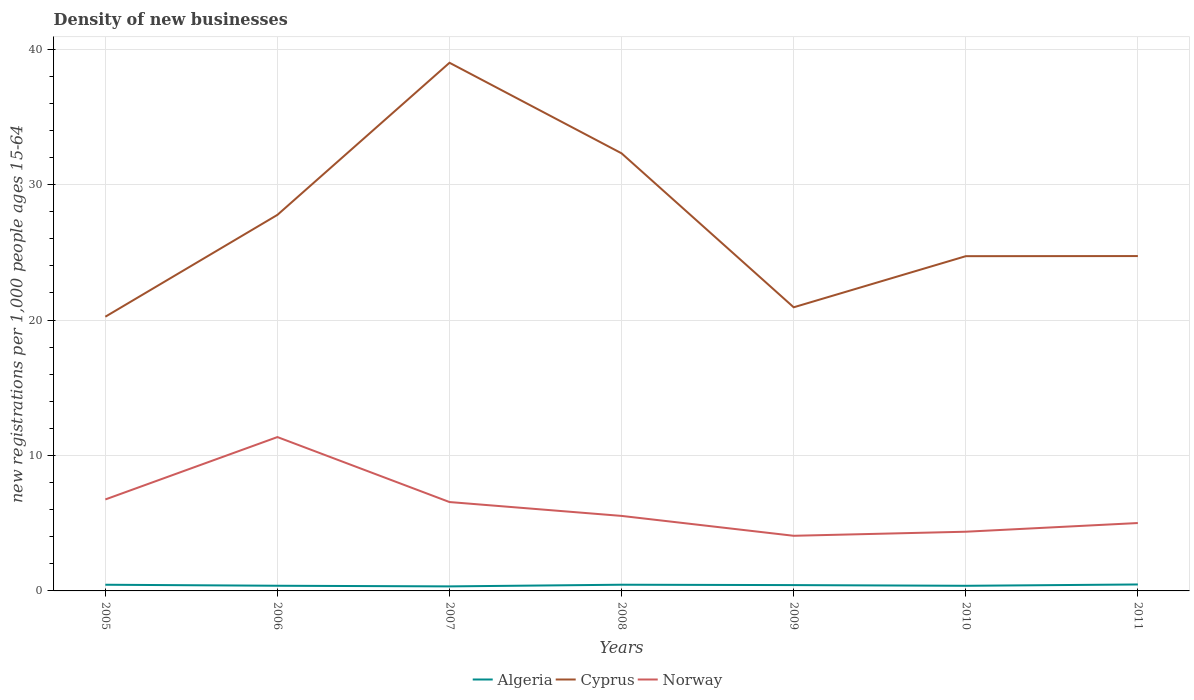How many different coloured lines are there?
Your answer should be compact. 3. Is the number of lines equal to the number of legend labels?
Your answer should be compact. Yes. Across all years, what is the maximum number of new registrations in Algeria?
Provide a succinct answer. 0.33. In which year was the number of new registrations in Norway maximum?
Offer a very short reply. 2009. What is the total number of new registrations in Norway in the graph?
Your response must be concise. 4.8. What is the difference between the highest and the second highest number of new registrations in Algeria?
Offer a very short reply. 0.14. What is the difference between the highest and the lowest number of new registrations in Norway?
Provide a succinct answer. 3. How many years are there in the graph?
Your response must be concise. 7. Does the graph contain any zero values?
Keep it short and to the point. No. Where does the legend appear in the graph?
Ensure brevity in your answer.  Bottom center. How are the legend labels stacked?
Your answer should be compact. Horizontal. What is the title of the graph?
Give a very brief answer. Density of new businesses. What is the label or title of the X-axis?
Your answer should be very brief. Years. What is the label or title of the Y-axis?
Give a very brief answer. New registrations per 1,0 people ages 15-64. What is the new registrations per 1,000 people ages 15-64 in Algeria in 2005?
Ensure brevity in your answer.  0.46. What is the new registrations per 1,000 people ages 15-64 of Cyprus in 2005?
Offer a very short reply. 20.25. What is the new registrations per 1,000 people ages 15-64 in Norway in 2005?
Provide a short and direct response. 6.75. What is the new registrations per 1,000 people ages 15-64 of Algeria in 2006?
Offer a terse response. 0.38. What is the new registrations per 1,000 people ages 15-64 of Cyprus in 2006?
Your answer should be very brief. 27.77. What is the new registrations per 1,000 people ages 15-64 in Norway in 2006?
Give a very brief answer. 11.36. What is the new registrations per 1,000 people ages 15-64 in Algeria in 2007?
Give a very brief answer. 0.33. What is the new registrations per 1,000 people ages 15-64 of Cyprus in 2007?
Offer a very short reply. 39. What is the new registrations per 1,000 people ages 15-64 in Norway in 2007?
Ensure brevity in your answer.  6.56. What is the new registrations per 1,000 people ages 15-64 of Algeria in 2008?
Give a very brief answer. 0.46. What is the new registrations per 1,000 people ages 15-64 of Cyprus in 2008?
Make the answer very short. 32.31. What is the new registrations per 1,000 people ages 15-64 of Norway in 2008?
Provide a succinct answer. 5.54. What is the new registrations per 1,000 people ages 15-64 of Algeria in 2009?
Offer a terse response. 0.43. What is the new registrations per 1,000 people ages 15-64 in Cyprus in 2009?
Your answer should be very brief. 20.94. What is the new registrations per 1,000 people ages 15-64 in Norway in 2009?
Your answer should be very brief. 4.07. What is the new registrations per 1,000 people ages 15-64 in Algeria in 2010?
Ensure brevity in your answer.  0.38. What is the new registrations per 1,000 people ages 15-64 in Cyprus in 2010?
Make the answer very short. 24.72. What is the new registrations per 1,000 people ages 15-64 of Norway in 2010?
Give a very brief answer. 4.37. What is the new registrations per 1,000 people ages 15-64 in Algeria in 2011?
Provide a succinct answer. 0.48. What is the new registrations per 1,000 people ages 15-64 in Cyprus in 2011?
Provide a succinct answer. 24.73. What is the new registrations per 1,000 people ages 15-64 of Norway in 2011?
Make the answer very short. 5.01. Across all years, what is the maximum new registrations per 1,000 people ages 15-64 of Algeria?
Offer a very short reply. 0.48. Across all years, what is the maximum new registrations per 1,000 people ages 15-64 of Cyprus?
Provide a short and direct response. 39. Across all years, what is the maximum new registrations per 1,000 people ages 15-64 of Norway?
Give a very brief answer. 11.36. Across all years, what is the minimum new registrations per 1,000 people ages 15-64 in Algeria?
Give a very brief answer. 0.33. Across all years, what is the minimum new registrations per 1,000 people ages 15-64 of Cyprus?
Your response must be concise. 20.25. Across all years, what is the minimum new registrations per 1,000 people ages 15-64 of Norway?
Your answer should be compact. 4.07. What is the total new registrations per 1,000 people ages 15-64 of Algeria in the graph?
Provide a short and direct response. 2.92. What is the total new registrations per 1,000 people ages 15-64 in Cyprus in the graph?
Offer a very short reply. 189.72. What is the total new registrations per 1,000 people ages 15-64 of Norway in the graph?
Offer a terse response. 43.67. What is the difference between the new registrations per 1,000 people ages 15-64 of Algeria in 2005 and that in 2006?
Your answer should be compact. 0.08. What is the difference between the new registrations per 1,000 people ages 15-64 in Cyprus in 2005 and that in 2006?
Your answer should be compact. -7.52. What is the difference between the new registrations per 1,000 people ages 15-64 in Norway in 2005 and that in 2006?
Make the answer very short. -4.61. What is the difference between the new registrations per 1,000 people ages 15-64 of Algeria in 2005 and that in 2007?
Provide a short and direct response. 0.12. What is the difference between the new registrations per 1,000 people ages 15-64 of Cyprus in 2005 and that in 2007?
Make the answer very short. -18.75. What is the difference between the new registrations per 1,000 people ages 15-64 of Norway in 2005 and that in 2007?
Your answer should be very brief. 0.19. What is the difference between the new registrations per 1,000 people ages 15-64 of Algeria in 2005 and that in 2008?
Ensure brevity in your answer.  -0. What is the difference between the new registrations per 1,000 people ages 15-64 of Cyprus in 2005 and that in 2008?
Make the answer very short. -12.06. What is the difference between the new registrations per 1,000 people ages 15-64 of Norway in 2005 and that in 2008?
Give a very brief answer. 1.22. What is the difference between the new registrations per 1,000 people ages 15-64 in Algeria in 2005 and that in 2009?
Offer a very short reply. 0.03. What is the difference between the new registrations per 1,000 people ages 15-64 of Cyprus in 2005 and that in 2009?
Give a very brief answer. -0.7. What is the difference between the new registrations per 1,000 people ages 15-64 of Norway in 2005 and that in 2009?
Make the answer very short. 2.68. What is the difference between the new registrations per 1,000 people ages 15-64 in Algeria in 2005 and that in 2010?
Provide a succinct answer. 0.08. What is the difference between the new registrations per 1,000 people ages 15-64 in Cyprus in 2005 and that in 2010?
Provide a short and direct response. -4.47. What is the difference between the new registrations per 1,000 people ages 15-64 in Norway in 2005 and that in 2010?
Provide a succinct answer. 2.38. What is the difference between the new registrations per 1,000 people ages 15-64 in Algeria in 2005 and that in 2011?
Your response must be concise. -0.02. What is the difference between the new registrations per 1,000 people ages 15-64 of Cyprus in 2005 and that in 2011?
Ensure brevity in your answer.  -4.48. What is the difference between the new registrations per 1,000 people ages 15-64 in Norway in 2005 and that in 2011?
Provide a succinct answer. 1.74. What is the difference between the new registrations per 1,000 people ages 15-64 in Algeria in 2006 and that in 2007?
Offer a very short reply. 0.05. What is the difference between the new registrations per 1,000 people ages 15-64 in Cyprus in 2006 and that in 2007?
Your response must be concise. -11.23. What is the difference between the new registrations per 1,000 people ages 15-64 in Norway in 2006 and that in 2007?
Provide a short and direct response. 4.8. What is the difference between the new registrations per 1,000 people ages 15-64 of Algeria in 2006 and that in 2008?
Give a very brief answer. -0.08. What is the difference between the new registrations per 1,000 people ages 15-64 of Cyprus in 2006 and that in 2008?
Your answer should be very brief. -4.54. What is the difference between the new registrations per 1,000 people ages 15-64 in Norway in 2006 and that in 2008?
Offer a terse response. 5.82. What is the difference between the new registrations per 1,000 people ages 15-64 of Algeria in 2006 and that in 2009?
Offer a very short reply. -0.05. What is the difference between the new registrations per 1,000 people ages 15-64 of Cyprus in 2006 and that in 2009?
Ensure brevity in your answer.  6.83. What is the difference between the new registrations per 1,000 people ages 15-64 in Norway in 2006 and that in 2009?
Give a very brief answer. 7.29. What is the difference between the new registrations per 1,000 people ages 15-64 of Algeria in 2006 and that in 2010?
Your answer should be very brief. 0. What is the difference between the new registrations per 1,000 people ages 15-64 in Cyprus in 2006 and that in 2010?
Ensure brevity in your answer.  3.05. What is the difference between the new registrations per 1,000 people ages 15-64 of Norway in 2006 and that in 2010?
Provide a short and direct response. 6.99. What is the difference between the new registrations per 1,000 people ages 15-64 in Algeria in 2006 and that in 2011?
Provide a short and direct response. -0.1. What is the difference between the new registrations per 1,000 people ages 15-64 of Cyprus in 2006 and that in 2011?
Keep it short and to the point. 3.04. What is the difference between the new registrations per 1,000 people ages 15-64 of Norway in 2006 and that in 2011?
Keep it short and to the point. 6.35. What is the difference between the new registrations per 1,000 people ages 15-64 in Algeria in 2007 and that in 2008?
Offer a very short reply. -0.12. What is the difference between the new registrations per 1,000 people ages 15-64 in Cyprus in 2007 and that in 2008?
Your response must be concise. 6.69. What is the difference between the new registrations per 1,000 people ages 15-64 in Norway in 2007 and that in 2008?
Provide a short and direct response. 1.02. What is the difference between the new registrations per 1,000 people ages 15-64 of Algeria in 2007 and that in 2009?
Provide a succinct answer. -0.1. What is the difference between the new registrations per 1,000 people ages 15-64 of Cyprus in 2007 and that in 2009?
Make the answer very short. 18.06. What is the difference between the new registrations per 1,000 people ages 15-64 of Norway in 2007 and that in 2009?
Your answer should be very brief. 2.49. What is the difference between the new registrations per 1,000 people ages 15-64 of Algeria in 2007 and that in 2010?
Your answer should be compact. -0.04. What is the difference between the new registrations per 1,000 people ages 15-64 of Cyprus in 2007 and that in 2010?
Keep it short and to the point. 14.28. What is the difference between the new registrations per 1,000 people ages 15-64 of Norway in 2007 and that in 2010?
Your response must be concise. 2.19. What is the difference between the new registrations per 1,000 people ages 15-64 of Algeria in 2007 and that in 2011?
Give a very brief answer. -0.14. What is the difference between the new registrations per 1,000 people ages 15-64 in Cyprus in 2007 and that in 2011?
Provide a short and direct response. 14.27. What is the difference between the new registrations per 1,000 people ages 15-64 of Norway in 2007 and that in 2011?
Keep it short and to the point. 1.55. What is the difference between the new registrations per 1,000 people ages 15-64 in Algeria in 2008 and that in 2009?
Your answer should be compact. 0.03. What is the difference between the new registrations per 1,000 people ages 15-64 in Cyprus in 2008 and that in 2009?
Ensure brevity in your answer.  11.37. What is the difference between the new registrations per 1,000 people ages 15-64 in Norway in 2008 and that in 2009?
Offer a very short reply. 1.47. What is the difference between the new registrations per 1,000 people ages 15-64 in Algeria in 2008 and that in 2010?
Make the answer very short. 0.08. What is the difference between the new registrations per 1,000 people ages 15-64 in Cyprus in 2008 and that in 2010?
Provide a succinct answer. 7.59. What is the difference between the new registrations per 1,000 people ages 15-64 in Norway in 2008 and that in 2010?
Offer a very short reply. 1.17. What is the difference between the new registrations per 1,000 people ages 15-64 in Algeria in 2008 and that in 2011?
Keep it short and to the point. -0.02. What is the difference between the new registrations per 1,000 people ages 15-64 of Cyprus in 2008 and that in 2011?
Give a very brief answer. 7.58. What is the difference between the new registrations per 1,000 people ages 15-64 in Norway in 2008 and that in 2011?
Your answer should be compact. 0.53. What is the difference between the new registrations per 1,000 people ages 15-64 in Algeria in 2009 and that in 2010?
Provide a short and direct response. 0.05. What is the difference between the new registrations per 1,000 people ages 15-64 of Cyprus in 2009 and that in 2010?
Your answer should be compact. -3.77. What is the difference between the new registrations per 1,000 people ages 15-64 of Norway in 2009 and that in 2010?
Ensure brevity in your answer.  -0.3. What is the difference between the new registrations per 1,000 people ages 15-64 of Algeria in 2009 and that in 2011?
Make the answer very short. -0.05. What is the difference between the new registrations per 1,000 people ages 15-64 in Cyprus in 2009 and that in 2011?
Provide a short and direct response. -3.78. What is the difference between the new registrations per 1,000 people ages 15-64 of Norway in 2009 and that in 2011?
Provide a succinct answer. -0.94. What is the difference between the new registrations per 1,000 people ages 15-64 of Algeria in 2010 and that in 2011?
Give a very brief answer. -0.1. What is the difference between the new registrations per 1,000 people ages 15-64 of Cyprus in 2010 and that in 2011?
Keep it short and to the point. -0.01. What is the difference between the new registrations per 1,000 people ages 15-64 of Norway in 2010 and that in 2011?
Your answer should be very brief. -0.64. What is the difference between the new registrations per 1,000 people ages 15-64 of Algeria in 2005 and the new registrations per 1,000 people ages 15-64 of Cyprus in 2006?
Ensure brevity in your answer.  -27.31. What is the difference between the new registrations per 1,000 people ages 15-64 in Algeria in 2005 and the new registrations per 1,000 people ages 15-64 in Norway in 2006?
Your answer should be compact. -10.9. What is the difference between the new registrations per 1,000 people ages 15-64 of Cyprus in 2005 and the new registrations per 1,000 people ages 15-64 of Norway in 2006?
Your answer should be compact. 8.89. What is the difference between the new registrations per 1,000 people ages 15-64 in Algeria in 2005 and the new registrations per 1,000 people ages 15-64 in Cyprus in 2007?
Your answer should be compact. -38.54. What is the difference between the new registrations per 1,000 people ages 15-64 in Algeria in 2005 and the new registrations per 1,000 people ages 15-64 in Norway in 2007?
Ensure brevity in your answer.  -6.11. What is the difference between the new registrations per 1,000 people ages 15-64 of Cyprus in 2005 and the new registrations per 1,000 people ages 15-64 of Norway in 2007?
Ensure brevity in your answer.  13.69. What is the difference between the new registrations per 1,000 people ages 15-64 of Algeria in 2005 and the new registrations per 1,000 people ages 15-64 of Cyprus in 2008?
Your answer should be compact. -31.85. What is the difference between the new registrations per 1,000 people ages 15-64 of Algeria in 2005 and the new registrations per 1,000 people ages 15-64 of Norway in 2008?
Your answer should be very brief. -5.08. What is the difference between the new registrations per 1,000 people ages 15-64 in Cyprus in 2005 and the new registrations per 1,000 people ages 15-64 in Norway in 2008?
Give a very brief answer. 14.71. What is the difference between the new registrations per 1,000 people ages 15-64 in Algeria in 2005 and the new registrations per 1,000 people ages 15-64 in Cyprus in 2009?
Offer a terse response. -20.49. What is the difference between the new registrations per 1,000 people ages 15-64 in Algeria in 2005 and the new registrations per 1,000 people ages 15-64 in Norway in 2009?
Your answer should be very brief. -3.61. What is the difference between the new registrations per 1,000 people ages 15-64 in Cyprus in 2005 and the new registrations per 1,000 people ages 15-64 in Norway in 2009?
Give a very brief answer. 16.18. What is the difference between the new registrations per 1,000 people ages 15-64 of Algeria in 2005 and the new registrations per 1,000 people ages 15-64 of Cyprus in 2010?
Ensure brevity in your answer.  -24.26. What is the difference between the new registrations per 1,000 people ages 15-64 of Algeria in 2005 and the new registrations per 1,000 people ages 15-64 of Norway in 2010?
Your response must be concise. -3.91. What is the difference between the new registrations per 1,000 people ages 15-64 in Cyprus in 2005 and the new registrations per 1,000 people ages 15-64 in Norway in 2010?
Your answer should be very brief. 15.88. What is the difference between the new registrations per 1,000 people ages 15-64 of Algeria in 2005 and the new registrations per 1,000 people ages 15-64 of Cyprus in 2011?
Provide a succinct answer. -24.27. What is the difference between the new registrations per 1,000 people ages 15-64 of Algeria in 2005 and the new registrations per 1,000 people ages 15-64 of Norway in 2011?
Make the answer very short. -4.56. What is the difference between the new registrations per 1,000 people ages 15-64 in Cyprus in 2005 and the new registrations per 1,000 people ages 15-64 in Norway in 2011?
Make the answer very short. 15.23. What is the difference between the new registrations per 1,000 people ages 15-64 in Algeria in 2006 and the new registrations per 1,000 people ages 15-64 in Cyprus in 2007?
Keep it short and to the point. -38.62. What is the difference between the new registrations per 1,000 people ages 15-64 of Algeria in 2006 and the new registrations per 1,000 people ages 15-64 of Norway in 2007?
Your response must be concise. -6.18. What is the difference between the new registrations per 1,000 people ages 15-64 in Cyprus in 2006 and the new registrations per 1,000 people ages 15-64 in Norway in 2007?
Make the answer very short. 21.21. What is the difference between the new registrations per 1,000 people ages 15-64 in Algeria in 2006 and the new registrations per 1,000 people ages 15-64 in Cyprus in 2008?
Ensure brevity in your answer.  -31.93. What is the difference between the new registrations per 1,000 people ages 15-64 in Algeria in 2006 and the new registrations per 1,000 people ages 15-64 in Norway in 2008?
Give a very brief answer. -5.16. What is the difference between the new registrations per 1,000 people ages 15-64 in Cyprus in 2006 and the new registrations per 1,000 people ages 15-64 in Norway in 2008?
Provide a short and direct response. 22.23. What is the difference between the new registrations per 1,000 people ages 15-64 in Algeria in 2006 and the new registrations per 1,000 people ages 15-64 in Cyprus in 2009?
Your response must be concise. -20.56. What is the difference between the new registrations per 1,000 people ages 15-64 in Algeria in 2006 and the new registrations per 1,000 people ages 15-64 in Norway in 2009?
Offer a terse response. -3.69. What is the difference between the new registrations per 1,000 people ages 15-64 in Cyprus in 2006 and the new registrations per 1,000 people ages 15-64 in Norway in 2009?
Provide a short and direct response. 23.7. What is the difference between the new registrations per 1,000 people ages 15-64 of Algeria in 2006 and the new registrations per 1,000 people ages 15-64 of Cyprus in 2010?
Keep it short and to the point. -24.34. What is the difference between the new registrations per 1,000 people ages 15-64 of Algeria in 2006 and the new registrations per 1,000 people ages 15-64 of Norway in 2010?
Your response must be concise. -3.99. What is the difference between the new registrations per 1,000 people ages 15-64 in Cyprus in 2006 and the new registrations per 1,000 people ages 15-64 in Norway in 2010?
Your response must be concise. 23.4. What is the difference between the new registrations per 1,000 people ages 15-64 of Algeria in 2006 and the new registrations per 1,000 people ages 15-64 of Cyprus in 2011?
Your answer should be compact. -24.34. What is the difference between the new registrations per 1,000 people ages 15-64 of Algeria in 2006 and the new registrations per 1,000 people ages 15-64 of Norway in 2011?
Your answer should be very brief. -4.63. What is the difference between the new registrations per 1,000 people ages 15-64 of Cyprus in 2006 and the new registrations per 1,000 people ages 15-64 of Norway in 2011?
Provide a succinct answer. 22.76. What is the difference between the new registrations per 1,000 people ages 15-64 in Algeria in 2007 and the new registrations per 1,000 people ages 15-64 in Cyprus in 2008?
Keep it short and to the point. -31.98. What is the difference between the new registrations per 1,000 people ages 15-64 of Algeria in 2007 and the new registrations per 1,000 people ages 15-64 of Norway in 2008?
Ensure brevity in your answer.  -5.2. What is the difference between the new registrations per 1,000 people ages 15-64 in Cyprus in 2007 and the new registrations per 1,000 people ages 15-64 in Norway in 2008?
Keep it short and to the point. 33.46. What is the difference between the new registrations per 1,000 people ages 15-64 in Algeria in 2007 and the new registrations per 1,000 people ages 15-64 in Cyprus in 2009?
Provide a succinct answer. -20.61. What is the difference between the new registrations per 1,000 people ages 15-64 in Algeria in 2007 and the new registrations per 1,000 people ages 15-64 in Norway in 2009?
Keep it short and to the point. -3.74. What is the difference between the new registrations per 1,000 people ages 15-64 of Cyprus in 2007 and the new registrations per 1,000 people ages 15-64 of Norway in 2009?
Offer a terse response. 34.93. What is the difference between the new registrations per 1,000 people ages 15-64 of Algeria in 2007 and the new registrations per 1,000 people ages 15-64 of Cyprus in 2010?
Your response must be concise. -24.38. What is the difference between the new registrations per 1,000 people ages 15-64 of Algeria in 2007 and the new registrations per 1,000 people ages 15-64 of Norway in 2010?
Ensure brevity in your answer.  -4.04. What is the difference between the new registrations per 1,000 people ages 15-64 in Cyprus in 2007 and the new registrations per 1,000 people ages 15-64 in Norway in 2010?
Keep it short and to the point. 34.63. What is the difference between the new registrations per 1,000 people ages 15-64 in Algeria in 2007 and the new registrations per 1,000 people ages 15-64 in Cyprus in 2011?
Make the answer very short. -24.39. What is the difference between the new registrations per 1,000 people ages 15-64 in Algeria in 2007 and the new registrations per 1,000 people ages 15-64 in Norway in 2011?
Make the answer very short. -4.68. What is the difference between the new registrations per 1,000 people ages 15-64 of Cyprus in 2007 and the new registrations per 1,000 people ages 15-64 of Norway in 2011?
Ensure brevity in your answer.  33.99. What is the difference between the new registrations per 1,000 people ages 15-64 in Algeria in 2008 and the new registrations per 1,000 people ages 15-64 in Cyprus in 2009?
Your response must be concise. -20.49. What is the difference between the new registrations per 1,000 people ages 15-64 in Algeria in 2008 and the new registrations per 1,000 people ages 15-64 in Norway in 2009?
Provide a short and direct response. -3.61. What is the difference between the new registrations per 1,000 people ages 15-64 of Cyprus in 2008 and the new registrations per 1,000 people ages 15-64 of Norway in 2009?
Provide a short and direct response. 28.24. What is the difference between the new registrations per 1,000 people ages 15-64 of Algeria in 2008 and the new registrations per 1,000 people ages 15-64 of Cyprus in 2010?
Ensure brevity in your answer.  -24.26. What is the difference between the new registrations per 1,000 people ages 15-64 of Algeria in 2008 and the new registrations per 1,000 people ages 15-64 of Norway in 2010?
Offer a terse response. -3.91. What is the difference between the new registrations per 1,000 people ages 15-64 in Cyprus in 2008 and the new registrations per 1,000 people ages 15-64 in Norway in 2010?
Your response must be concise. 27.94. What is the difference between the new registrations per 1,000 people ages 15-64 in Algeria in 2008 and the new registrations per 1,000 people ages 15-64 in Cyprus in 2011?
Your response must be concise. -24.27. What is the difference between the new registrations per 1,000 people ages 15-64 of Algeria in 2008 and the new registrations per 1,000 people ages 15-64 of Norway in 2011?
Ensure brevity in your answer.  -4.56. What is the difference between the new registrations per 1,000 people ages 15-64 in Cyprus in 2008 and the new registrations per 1,000 people ages 15-64 in Norway in 2011?
Your answer should be compact. 27.3. What is the difference between the new registrations per 1,000 people ages 15-64 of Algeria in 2009 and the new registrations per 1,000 people ages 15-64 of Cyprus in 2010?
Ensure brevity in your answer.  -24.29. What is the difference between the new registrations per 1,000 people ages 15-64 of Algeria in 2009 and the new registrations per 1,000 people ages 15-64 of Norway in 2010?
Ensure brevity in your answer.  -3.94. What is the difference between the new registrations per 1,000 people ages 15-64 in Cyprus in 2009 and the new registrations per 1,000 people ages 15-64 in Norway in 2010?
Ensure brevity in your answer.  16.57. What is the difference between the new registrations per 1,000 people ages 15-64 in Algeria in 2009 and the new registrations per 1,000 people ages 15-64 in Cyprus in 2011?
Give a very brief answer. -24.3. What is the difference between the new registrations per 1,000 people ages 15-64 of Algeria in 2009 and the new registrations per 1,000 people ages 15-64 of Norway in 2011?
Give a very brief answer. -4.58. What is the difference between the new registrations per 1,000 people ages 15-64 of Cyprus in 2009 and the new registrations per 1,000 people ages 15-64 of Norway in 2011?
Ensure brevity in your answer.  15.93. What is the difference between the new registrations per 1,000 people ages 15-64 of Algeria in 2010 and the new registrations per 1,000 people ages 15-64 of Cyprus in 2011?
Your answer should be compact. -24.35. What is the difference between the new registrations per 1,000 people ages 15-64 of Algeria in 2010 and the new registrations per 1,000 people ages 15-64 of Norway in 2011?
Provide a short and direct response. -4.63. What is the difference between the new registrations per 1,000 people ages 15-64 in Cyprus in 2010 and the new registrations per 1,000 people ages 15-64 in Norway in 2011?
Your response must be concise. 19.71. What is the average new registrations per 1,000 people ages 15-64 in Algeria per year?
Your answer should be very brief. 0.42. What is the average new registrations per 1,000 people ages 15-64 of Cyprus per year?
Offer a very short reply. 27.1. What is the average new registrations per 1,000 people ages 15-64 in Norway per year?
Your answer should be very brief. 6.24. In the year 2005, what is the difference between the new registrations per 1,000 people ages 15-64 in Algeria and new registrations per 1,000 people ages 15-64 in Cyprus?
Your response must be concise. -19.79. In the year 2005, what is the difference between the new registrations per 1,000 people ages 15-64 in Algeria and new registrations per 1,000 people ages 15-64 in Norway?
Your answer should be very brief. -6.3. In the year 2005, what is the difference between the new registrations per 1,000 people ages 15-64 in Cyprus and new registrations per 1,000 people ages 15-64 in Norway?
Your answer should be very brief. 13.49. In the year 2006, what is the difference between the new registrations per 1,000 people ages 15-64 of Algeria and new registrations per 1,000 people ages 15-64 of Cyprus?
Your response must be concise. -27.39. In the year 2006, what is the difference between the new registrations per 1,000 people ages 15-64 in Algeria and new registrations per 1,000 people ages 15-64 in Norway?
Offer a very short reply. -10.98. In the year 2006, what is the difference between the new registrations per 1,000 people ages 15-64 of Cyprus and new registrations per 1,000 people ages 15-64 of Norway?
Your answer should be very brief. 16.41. In the year 2007, what is the difference between the new registrations per 1,000 people ages 15-64 in Algeria and new registrations per 1,000 people ages 15-64 in Cyprus?
Your answer should be compact. -38.67. In the year 2007, what is the difference between the new registrations per 1,000 people ages 15-64 in Algeria and new registrations per 1,000 people ages 15-64 in Norway?
Ensure brevity in your answer.  -6.23. In the year 2007, what is the difference between the new registrations per 1,000 people ages 15-64 of Cyprus and new registrations per 1,000 people ages 15-64 of Norway?
Provide a succinct answer. 32.44. In the year 2008, what is the difference between the new registrations per 1,000 people ages 15-64 of Algeria and new registrations per 1,000 people ages 15-64 of Cyprus?
Your answer should be very brief. -31.85. In the year 2008, what is the difference between the new registrations per 1,000 people ages 15-64 in Algeria and new registrations per 1,000 people ages 15-64 in Norway?
Offer a terse response. -5.08. In the year 2008, what is the difference between the new registrations per 1,000 people ages 15-64 of Cyprus and new registrations per 1,000 people ages 15-64 of Norway?
Your answer should be very brief. 26.77. In the year 2009, what is the difference between the new registrations per 1,000 people ages 15-64 in Algeria and new registrations per 1,000 people ages 15-64 in Cyprus?
Provide a succinct answer. -20.51. In the year 2009, what is the difference between the new registrations per 1,000 people ages 15-64 in Algeria and new registrations per 1,000 people ages 15-64 in Norway?
Offer a terse response. -3.64. In the year 2009, what is the difference between the new registrations per 1,000 people ages 15-64 in Cyprus and new registrations per 1,000 people ages 15-64 in Norway?
Ensure brevity in your answer.  16.87. In the year 2010, what is the difference between the new registrations per 1,000 people ages 15-64 in Algeria and new registrations per 1,000 people ages 15-64 in Cyprus?
Provide a succinct answer. -24.34. In the year 2010, what is the difference between the new registrations per 1,000 people ages 15-64 of Algeria and new registrations per 1,000 people ages 15-64 of Norway?
Offer a terse response. -3.99. In the year 2010, what is the difference between the new registrations per 1,000 people ages 15-64 of Cyprus and new registrations per 1,000 people ages 15-64 of Norway?
Keep it short and to the point. 20.35. In the year 2011, what is the difference between the new registrations per 1,000 people ages 15-64 of Algeria and new registrations per 1,000 people ages 15-64 of Cyprus?
Provide a short and direct response. -24.25. In the year 2011, what is the difference between the new registrations per 1,000 people ages 15-64 in Algeria and new registrations per 1,000 people ages 15-64 in Norway?
Offer a very short reply. -4.54. In the year 2011, what is the difference between the new registrations per 1,000 people ages 15-64 of Cyprus and new registrations per 1,000 people ages 15-64 of Norway?
Ensure brevity in your answer.  19.71. What is the ratio of the new registrations per 1,000 people ages 15-64 in Algeria in 2005 to that in 2006?
Provide a succinct answer. 1.2. What is the ratio of the new registrations per 1,000 people ages 15-64 of Cyprus in 2005 to that in 2006?
Ensure brevity in your answer.  0.73. What is the ratio of the new registrations per 1,000 people ages 15-64 of Norway in 2005 to that in 2006?
Give a very brief answer. 0.59. What is the ratio of the new registrations per 1,000 people ages 15-64 of Algeria in 2005 to that in 2007?
Your answer should be compact. 1.37. What is the ratio of the new registrations per 1,000 people ages 15-64 of Cyprus in 2005 to that in 2007?
Provide a succinct answer. 0.52. What is the ratio of the new registrations per 1,000 people ages 15-64 of Norway in 2005 to that in 2007?
Ensure brevity in your answer.  1.03. What is the ratio of the new registrations per 1,000 people ages 15-64 of Cyprus in 2005 to that in 2008?
Offer a very short reply. 0.63. What is the ratio of the new registrations per 1,000 people ages 15-64 in Norway in 2005 to that in 2008?
Keep it short and to the point. 1.22. What is the ratio of the new registrations per 1,000 people ages 15-64 of Algeria in 2005 to that in 2009?
Provide a succinct answer. 1.06. What is the ratio of the new registrations per 1,000 people ages 15-64 of Cyprus in 2005 to that in 2009?
Ensure brevity in your answer.  0.97. What is the ratio of the new registrations per 1,000 people ages 15-64 of Norway in 2005 to that in 2009?
Offer a terse response. 1.66. What is the ratio of the new registrations per 1,000 people ages 15-64 of Algeria in 2005 to that in 2010?
Offer a terse response. 1.21. What is the ratio of the new registrations per 1,000 people ages 15-64 of Cyprus in 2005 to that in 2010?
Make the answer very short. 0.82. What is the ratio of the new registrations per 1,000 people ages 15-64 of Norway in 2005 to that in 2010?
Provide a succinct answer. 1.55. What is the ratio of the new registrations per 1,000 people ages 15-64 of Algeria in 2005 to that in 2011?
Offer a very short reply. 0.96. What is the ratio of the new registrations per 1,000 people ages 15-64 of Cyprus in 2005 to that in 2011?
Offer a very short reply. 0.82. What is the ratio of the new registrations per 1,000 people ages 15-64 in Norway in 2005 to that in 2011?
Provide a short and direct response. 1.35. What is the ratio of the new registrations per 1,000 people ages 15-64 in Algeria in 2006 to that in 2007?
Your response must be concise. 1.14. What is the ratio of the new registrations per 1,000 people ages 15-64 in Cyprus in 2006 to that in 2007?
Ensure brevity in your answer.  0.71. What is the ratio of the new registrations per 1,000 people ages 15-64 of Norway in 2006 to that in 2007?
Keep it short and to the point. 1.73. What is the ratio of the new registrations per 1,000 people ages 15-64 of Algeria in 2006 to that in 2008?
Provide a succinct answer. 0.83. What is the ratio of the new registrations per 1,000 people ages 15-64 of Cyprus in 2006 to that in 2008?
Your response must be concise. 0.86. What is the ratio of the new registrations per 1,000 people ages 15-64 in Norway in 2006 to that in 2008?
Provide a short and direct response. 2.05. What is the ratio of the new registrations per 1,000 people ages 15-64 in Algeria in 2006 to that in 2009?
Give a very brief answer. 0.89. What is the ratio of the new registrations per 1,000 people ages 15-64 of Cyprus in 2006 to that in 2009?
Give a very brief answer. 1.33. What is the ratio of the new registrations per 1,000 people ages 15-64 of Norway in 2006 to that in 2009?
Offer a very short reply. 2.79. What is the ratio of the new registrations per 1,000 people ages 15-64 of Algeria in 2006 to that in 2010?
Keep it short and to the point. 1.01. What is the ratio of the new registrations per 1,000 people ages 15-64 of Cyprus in 2006 to that in 2010?
Provide a succinct answer. 1.12. What is the ratio of the new registrations per 1,000 people ages 15-64 in Norway in 2006 to that in 2010?
Your answer should be very brief. 2.6. What is the ratio of the new registrations per 1,000 people ages 15-64 of Algeria in 2006 to that in 2011?
Provide a succinct answer. 0.8. What is the ratio of the new registrations per 1,000 people ages 15-64 of Cyprus in 2006 to that in 2011?
Give a very brief answer. 1.12. What is the ratio of the new registrations per 1,000 people ages 15-64 of Norway in 2006 to that in 2011?
Your response must be concise. 2.27. What is the ratio of the new registrations per 1,000 people ages 15-64 in Algeria in 2007 to that in 2008?
Make the answer very short. 0.73. What is the ratio of the new registrations per 1,000 people ages 15-64 in Cyprus in 2007 to that in 2008?
Keep it short and to the point. 1.21. What is the ratio of the new registrations per 1,000 people ages 15-64 in Norway in 2007 to that in 2008?
Offer a terse response. 1.18. What is the ratio of the new registrations per 1,000 people ages 15-64 of Algeria in 2007 to that in 2009?
Provide a short and direct response. 0.78. What is the ratio of the new registrations per 1,000 people ages 15-64 in Cyprus in 2007 to that in 2009?
Ensure brevity in your answer.  1.86. What is the ratio of the new registrations per 1,000 people ages 15-64 of Norway in 2007 to that in 2009?
Offer a terse response. 1.61. What is the ratio of the new registrations per 1,000 people ages 15-64 in Algeria in 2007 to that in 2010?
Give a very brief answer. 0.88. What is the ratio of the new registrations per 1,000 people ages 15-64 in Cyprus in 2007 to that in 2010?
Offer a very short reply. 1.58. What is the ratio of the new registrations per 1,000 people ages 15-64 in Norway in 2007 to that in 2010?
Your response must be concise. 1.5. What is the ratio of the new registrations per 1,000 people ages 15-64 in Algeria in 2007 to that in 2011?
Ensure brevity in your answer.  0.7. What is the ratio of the new registrations per 1,000 people ages 15-64 in Cyprus in 2007 to that in 2011?
Ensure brevity in your answer.  1.58. What is the ratio of the new registrations per 1,000 people ages 15-64 of Norway in 2007 to that in 2011?
Make the answer very short. 1.31. What is the ratio of the new registrations per 1,000 people ages 15-64 of Algeria in 2008 to that in 2009?
Give a very brief answer. 1.06. What is the ratio of the new registrations per 1,000 people ages 15-64 in Cyprus in 2008 to that in 2009?
Provide a short and direct response. 1.54. What is the ratio of the new registrations per 1,000 people ages 15-64 of Norway in 2008 to that in 2009?
Offer a terse response. 1.36. What is the ratio of the new registrations per 1,000 people ages 15-64 in Algeria in 2008 to that in 2010?
Ensure brevity in your answer.  1.21. What is the ratio of the new registrations per 1,000 people ages 15-64 in Cyprus in 2008 to that in 2010?
Your response must be concise. 1.31. What is the ratio of the new registrations per 1,000 people ages 15-64 of Norway in 2008 to that in 2010?
Ensure brevity in your answer.  1.27. What is the ratio of the new registrations per 1,000 people ages 15-64 of Algeria in 2008 to that in 2011?
Your answer should be very brief. 0.96. What is the ratio of the new registrations per 1,000 people ages 15-64 in Cyprus in 2008 to that in 2011?
Offer a terse response. 1.31. What is the ratio of the new registrations per 1,000 people ages 15-64 in Norway in 2008 to that in 2011?
Offer a very short reply. 1.1. What is the ratio of the new registrations per 1,000 people ages 15-64 of Algeria in 2009 to that in 2010?
Give a very brief answer. 1.14. What is the ratio of the new registrations per 1,000 people ages 15-64 of Cyprus in 2009 to that in 2010?
Your answer should be very brief. 0.85. What is the ratio of the new registrations per 1,000 people ages 15-64 in Norway in 2009 to that in 2010?
Provide a short and direct response. 0.93. What is the ratio of the new registrations per 1,000 people ages 15-64 of Algeria in 2009 to that in 2011?
Provide a succinct answer. 0.9. What is the ratio of the new registrations per 1,000 people ages 15-64 of Cyprus in 2009 to that in 2011?
Provide a succinct answer. 0.85. What is the ratio of the new registrations per 1,000 people ages 15-64 in Norway in 2009 to that in 2011?
Give a very brief answer. 0.81. What is the ratio of the new registrations per 1,000 people ages 15-64 in Algeria in 2010 to that in 2011?
Your response must be concise. 0.79. What is the ratio of the new registrations per 1,000 people ages 15-64 in Norway in 2010 to that in 2011?
Provide a succinct answer. 0.87. What is the difference between the highest and the second highest new registrations per 1,000 people ages 15-64 in Algeria?
Ensure brevity in your answer.  0.02. What is the difference between the highest and the second highest new registrations per 1,000 people ages 15-64 of Cyprus?
Make the answer very short. 6.69. What is the difference between the highest and the second highest new registrations per 1,000 people ages 15-64 of Norway?
Keep it short and to the point. 4.61. What is the difference between the highest and the lowest new registrations per 1,000 people ages 15-64 in Algeria?
Ensure brevity in your answer.  0.14. What is the difference between the highest and the lowest new registrations per 1,000 people ages 15-64 of Cyprus?
Offer a very short reply. 18.75. What is the difference between the highest and the lowest new registrations per 1,000 people ages 15-64 in Norway?
Give a very brief answer. 7.29. 